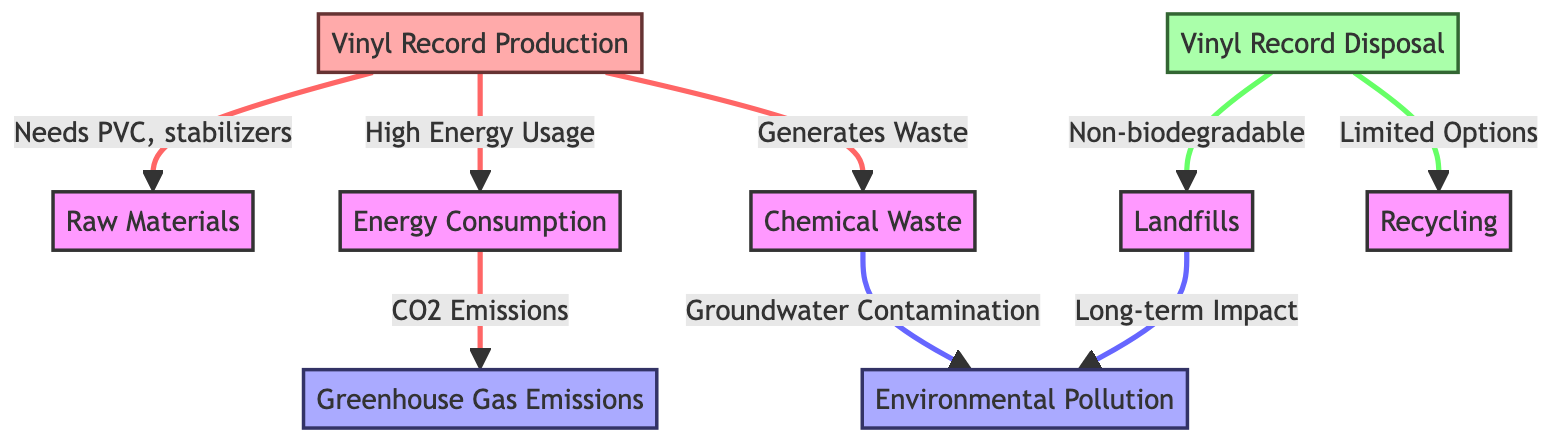What is the source of PVC needed in vinyl production? The diagram shows an arrow leading from "Vinyl Record Production" to "Raw Materials," indicating that PVC is one of the raw materials required for production. Therefore, the source is raw materials.
Answer: Raw Materials How does energy consumption contribute to greenhouse gas emissions? The diagram illustrates that "Energy Consumption" has a direct link to "Greenhouse Gas Emissions," indicating that energy consumption results in CO2 emissions. This shows a cause-and-effect relationship where energy use leads to emissions.
Answer: CO2 Emissions What type of waste is generated from the production of vinyl records? The diagram shows "Vinyl Record Production" leading to "Chemical Waste," suggesting that the production process generates chemical waste as a byproduct.
Answer: Chemical Waste How many disposal options are shown in the diagram? The diagram indicates two disposal options: "Landfills" and "Recycling." By counting the nodes related to record disposal, we find two clear disposal methods represented.
Answer: 2 What long-term impact is associated with landfills? An arrow from "Landfills" leads to "Environmental Pollution," indicating that the long-term impact of landfills is related to environmental pollution. This shows how waste can affect the environment over time.
Answer: Environmental Pollution What is a consequence of chemical waste in terms of environmental impact? The diagram connects "Chemical Waste" to "Groundwater Contamination," signifying that a consequence of chemical waste is the contamination of groundwater, which has significant environmental implications.
Answer: Groundwater Contamination What is the relationship between vinyl record disposal and recycling? The diagram indicates that "Record Disposal" leads to "Recycling," but with a note of "Limited Options," which suggests a restricted capacity or choice for recycling vinyl records, emphasizing the challenge of recycling them successfully.
Answer: Limited Options What color is used to represent the impact of environmental pollution in the diagram? The color coding in the diagram indicates that nodes related to environmental pollution are represented in a light blue shade, specifically categorized under "impact."
Answer: Light Blue Where does vinyl record production generate significant waste? The connection from "Vinyl Record Production" to "Chemical Waste" shows that significant waste is generated from this stage, directly pointing to the waste's type and origin within the production cycle.
Answer: Chemical Waste 